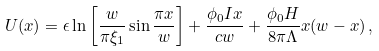Convert formula to latex. <formula><loc_0><loc_0><loc_500><loc_500>U ( x ) = \epsilon \ln \left [ \frac { w } { \pi \xi _ { 1 } } \sin \frac { \pi x } { w } \right ] + \frac { \phi _ { 0 } I x } { c w } + \frac { \phi _ { 0 } H } { 8 \pi \Lambda } x ( w - x ) \, ,</formula> 